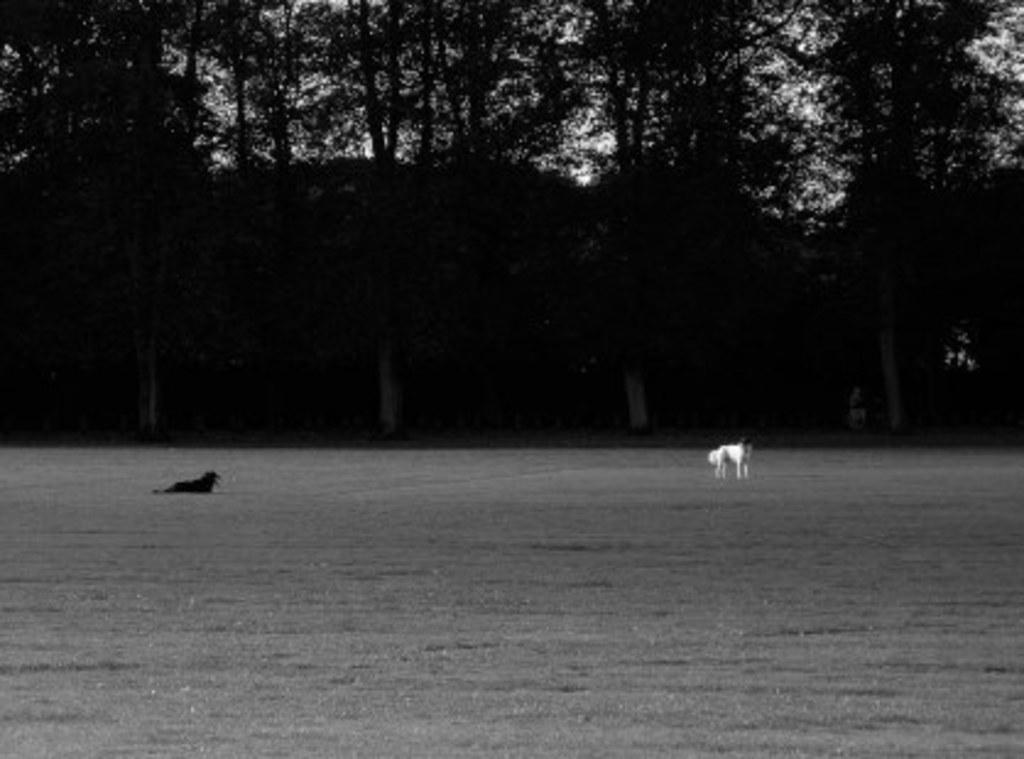What is the color scheme of the image? The image is black and white. What types of living organisms are present in the image? There are animals in the image. What type of vegetation is present in the image? There are trees in the image. What is visible in the background of the image? The sky is visible in the background of the image. Can you tell me how many trees are in the alley in the image? There is no alley present in the image, and therefore no trees can be found in an alley. 